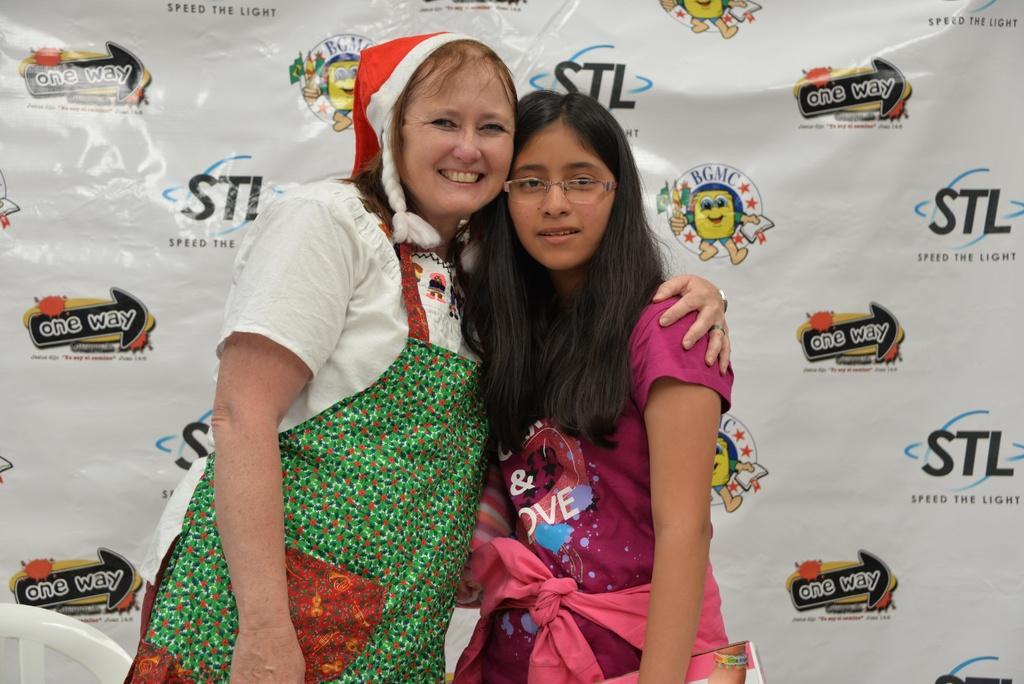Describe this image in one or two sentences. In the image we can see there are people standing and a woman is wearing christmas cap. Behind there is a banner. 